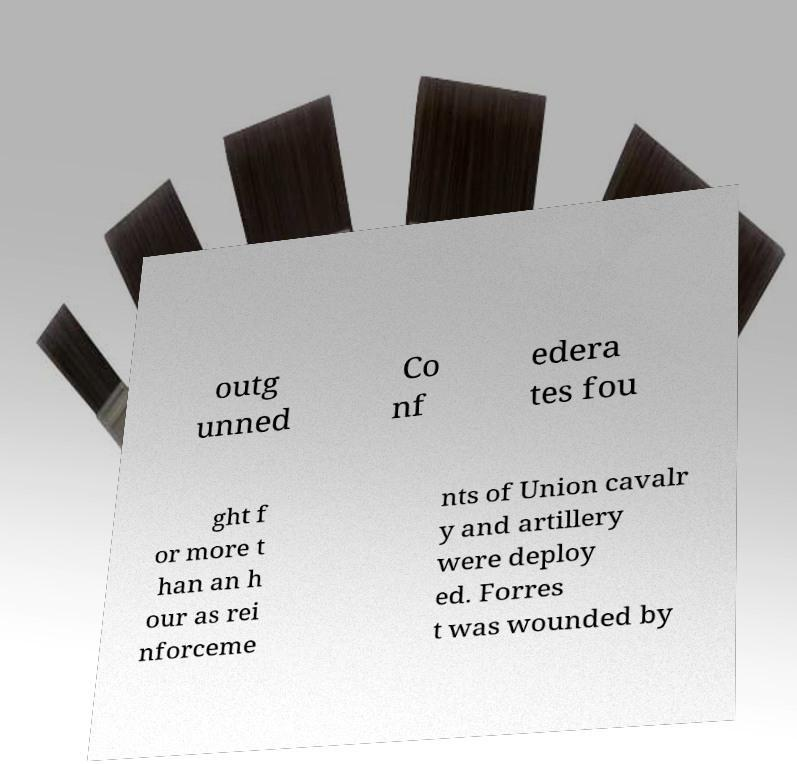Could you extract and type out the text from this image? outg unned Co nf edera tes fou ght f or more t han an h our as rei nforceme nts of Union cavalr y and artillery were deploy ed. Forres t was wounded by 